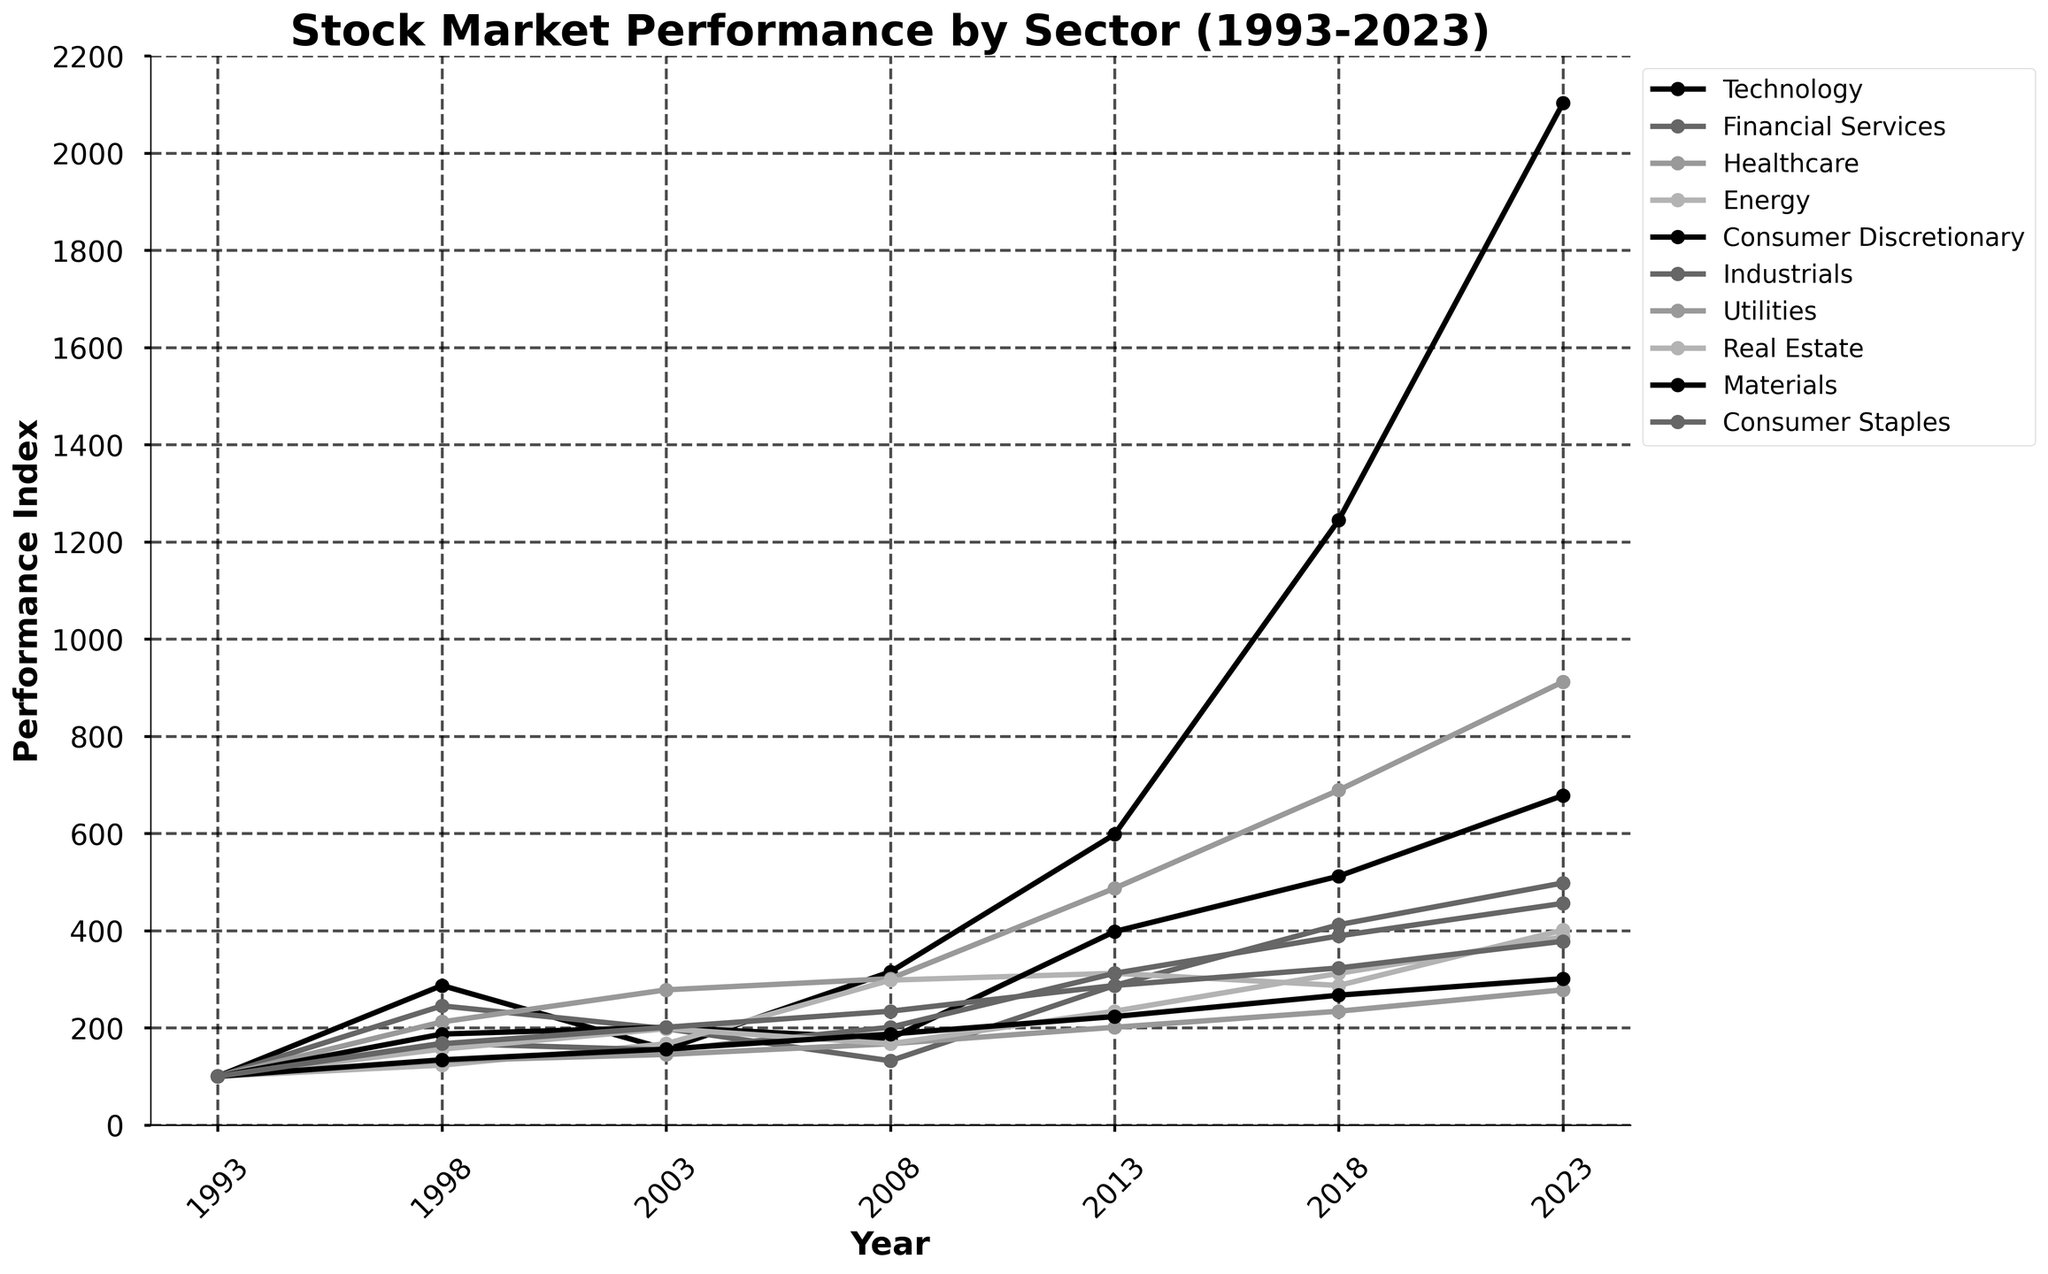What has been the trend for the Technology sector from 1993 to 2023? The Technology sector starts at 100 in 1993 and rises to 2103 in 2023. This represents a consistent upward trend with some variability in the intermediate years, notably a dip in 2003 and a significant rise after 2013.
Answer: Upward trend Which sector had the lowest performance index in 2008? In 2008, the Financial Services sector had the lowest performance index at 132, which is visibly the lowest point among all sectors for that year.
Answer: Financial Services How much did the Healthcare sector grow between 2008 and 2023? The Healthcare sector’s performance index in 2008 was 301, and it rose to 912 in 2023. The growth can be calculated by subtracting the 2008 value from the 2023 value: 912 - 301 = 611.
Answer: 611 Which two sectors had similar performance indices in 2018? In 2018, the Financial Services sector had a performance index of 412, and the Industrials had 389. These values are close to each other compared to other sector pairs.
Answer: Financial Services and Industrials Identify a sector that experienced a decline between 2013 and 2018. The Energy sector had a performance index of 312 in 2013 and it decreased to 287 by 2018, indicating a decline in that period.
Answer: Energy What is the maximum indexed value among all sectors in 2023? The Technology sector has the highest performance index in 2023 at 2103, which is the maximum value shown in that year.
Answer: 2103 Between 1993 and 1998, which sector had the highest percentage increase? The Technology sector had an increase from 100 in 1993 to 287 in 1998. The percentage increase is calculated as [(287-100)/100] * 100 = 187%. This is higher than any other sector's percentage increase in that period.
Answer: Technology How does the performance of Consumer Staples compare to Consumer Discretionary in 2023? In 2023, the Consumer Staples sector has a performance index of 378, while the Consumer Discretionary sector has 678. Consumer Discretionary is performing better by 678 - 378 = 300 points.
Answer: Consumer Discretionary Did any sector show a flat or very minimal change between any two consecutive periods? The Utilities sector exhibited minimal change between 2003 (145) and 2008 (167), showing only a small increase of 22 points over five years.
Answer: Utilities (2003-2008) 